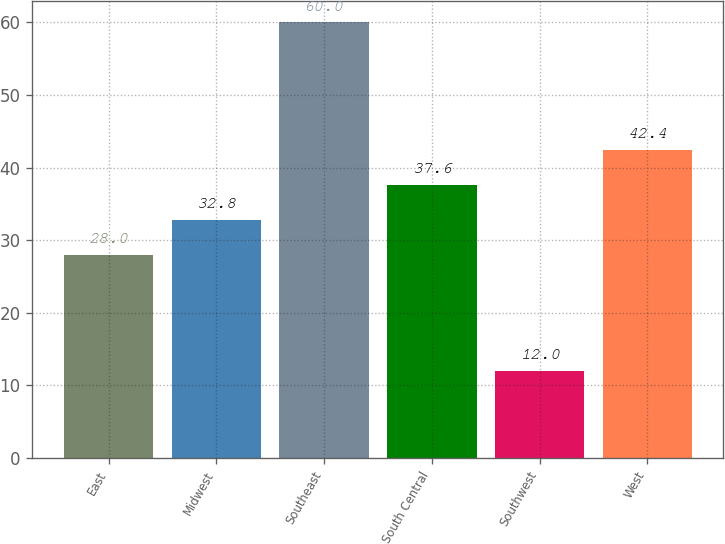Convert chart to OTSL. <chart><loc_0><loc_0><loc_500><loc_500><bar_chart><fcel>East<fcel>Midwest<fcel>Southeast<fcel>South Central<fcel>Southwest<fcel>West<nl><fcel>28<fcel>32.8<fcel>60<fcel>37.6<fcel>12<fcel>42.4<nl></chart> 